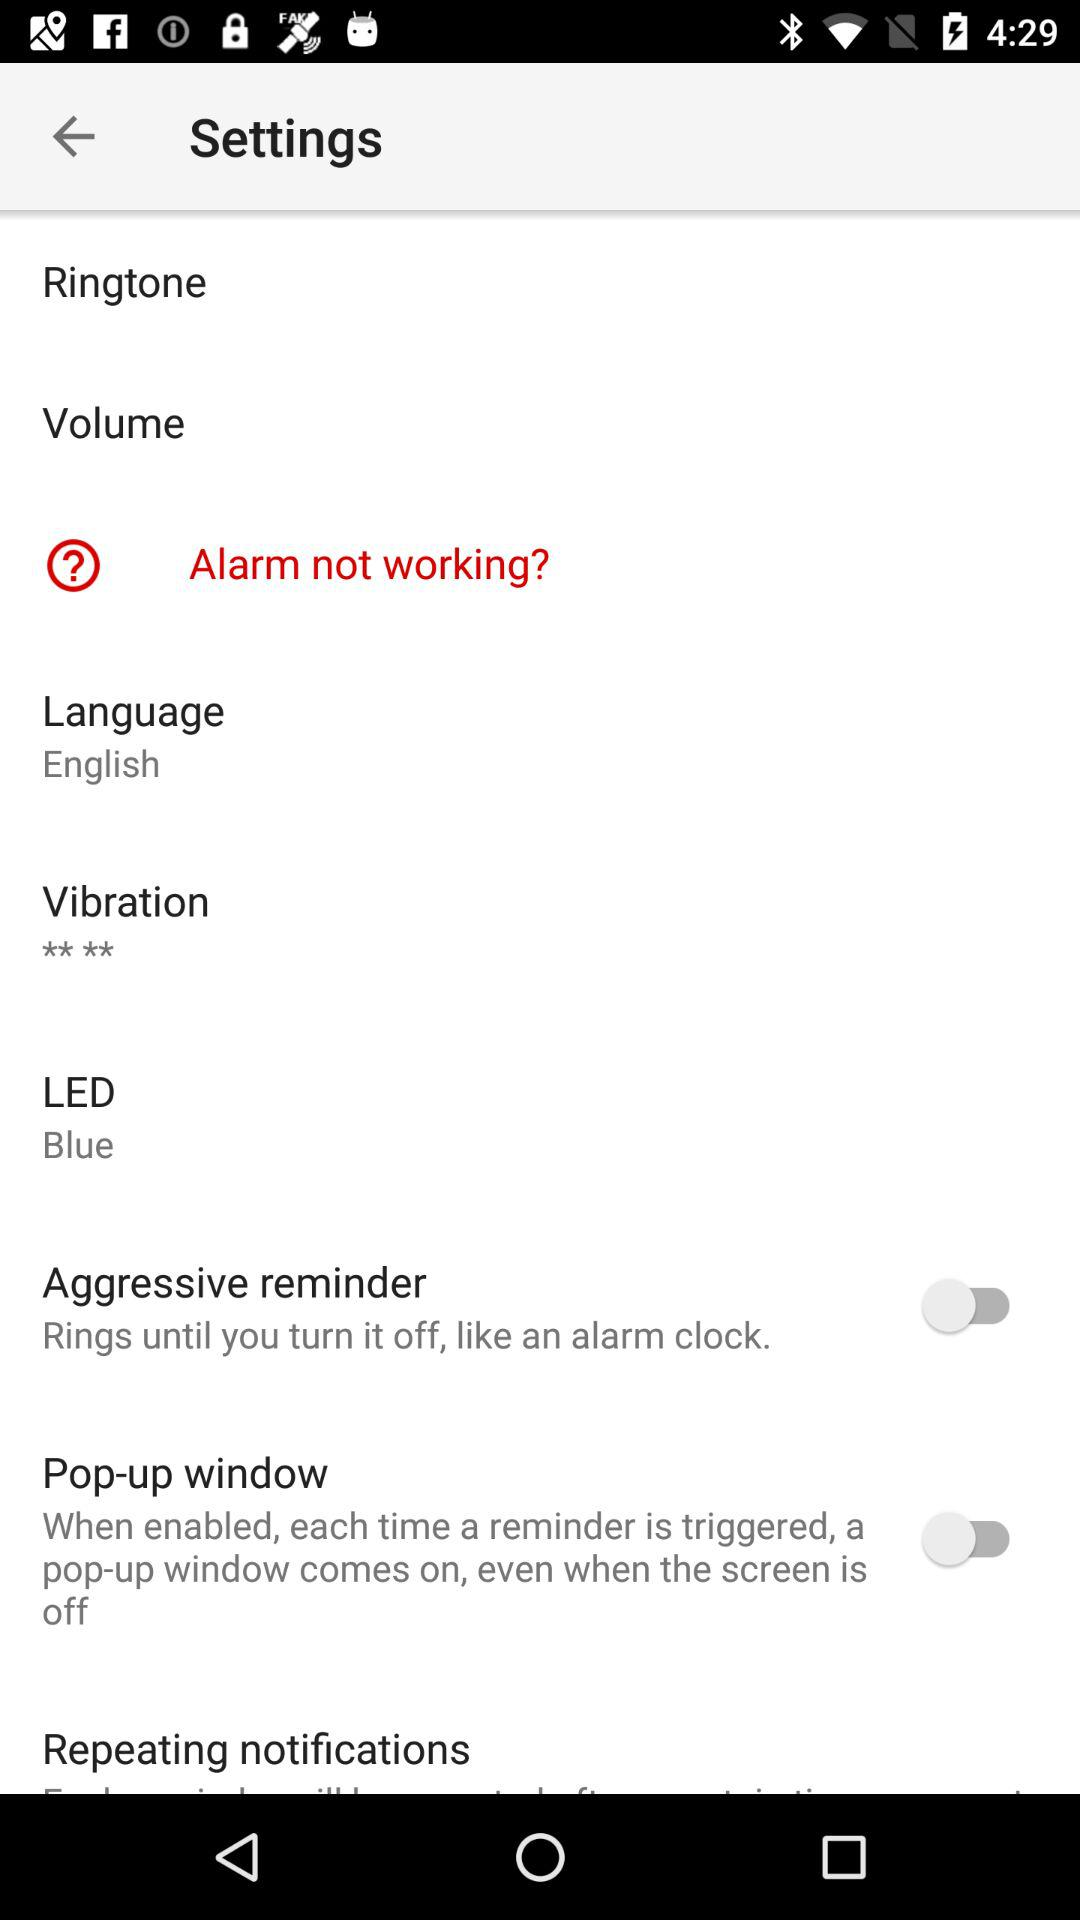What LED light is selected? The selected LED light is blue. 